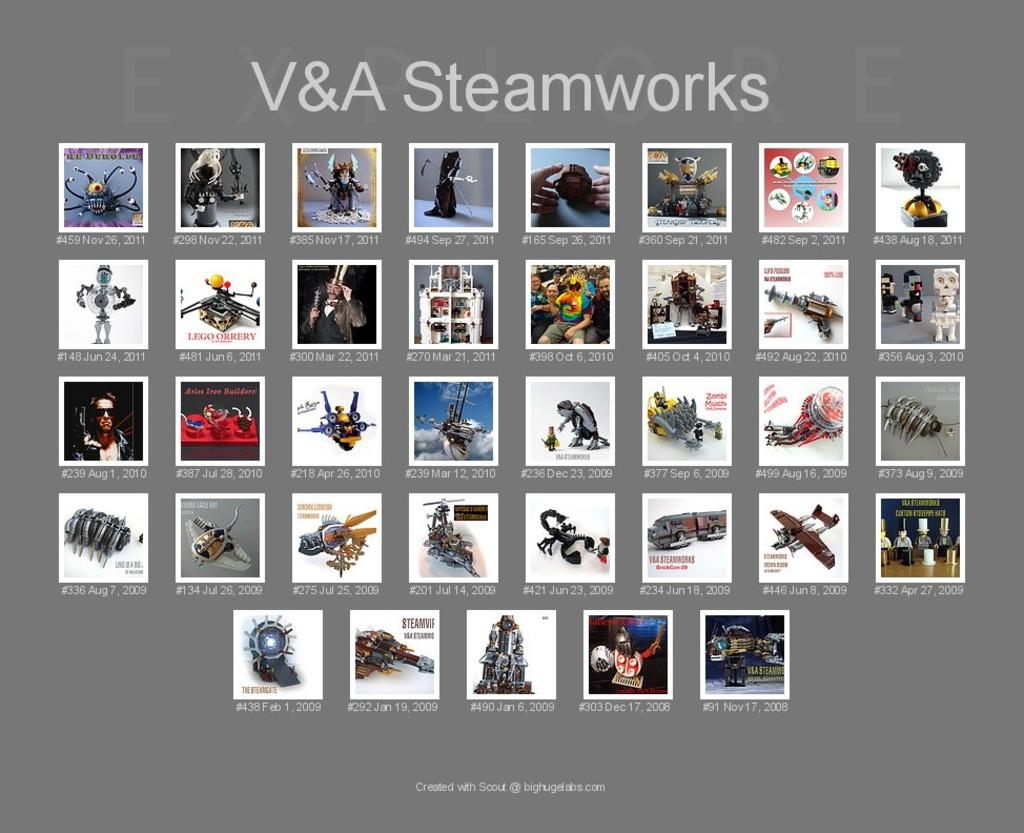What is the main object in the image that resembles a screen? There is an object in the image that resembles a screen. What can be seen on the screen? The screen displays different types of images. Is there any text present on the screen? Yes, there is text present on the screen. How does the screen help beginners achieve harmony in the image? There is no mention of beginners or harmony in the image, as the facts only describe the screen and its contents. 